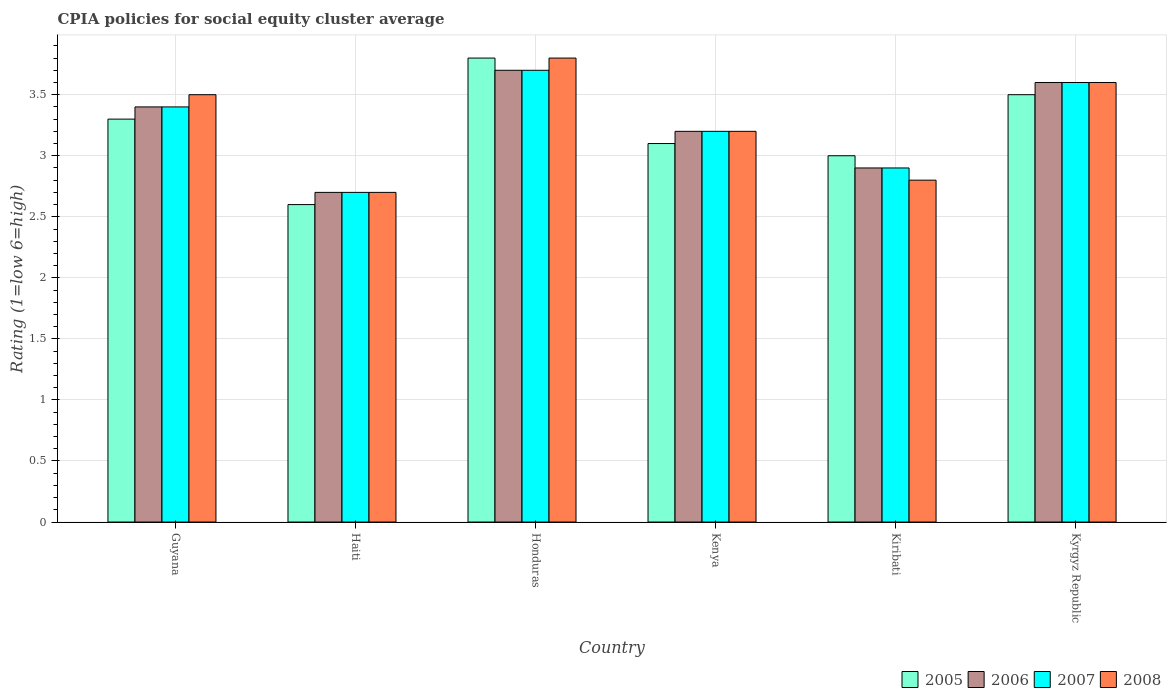Are the number of bars per tick equal to the number of legend labels?
Your response must be concise. Yes. How many bars are there on the 5th tick from the right?
Offer a terse response. 4. What is the label of the 1st group of bars from the left?
Your answer should be compact. Guyana. What is the CPIA rating in 2008 in Kyrgyz Republic?
Provide a short and direct response. 3.6. Across all countries, what is the maximum CPIA rating in 2007?
Provide a short and direct response. 3.7. Across all countries, what is the minimum CPIA rating in 2005?
Make the answer very short. 2.6. In which country was the CPIA rating in 2006 maximum?
Provide a short and direct response. Honduras. In which country was the CPIA rating in 2007 minimum?
Keep it short and to the point. Haiti. What is the total CPIA rating in 2005 in the graph?
Offer a terse response. 19.3. What is the difference between the CPIA rating in 2008 in Honduras and that in Kyrgyz Republic?
Provide a short and direct response. 0.2. What is the average CPIA rating in 2006 per country?
Give a very brief answer. 3.25. What is the difference between the CPIA rating of/in 2005 and CPIA rating of/in 2006 in Honduras?
Make the answer very short. 0.1. What is the ratio of the CPIA rating in 2005 in Kiribati to that in Kyrgyz Republic?
Keep it short and to the point. 0.86. Is the difference between the CPIA rating in 2005 in Haiti and Honduras greater than the difference between the CPIA rating in 2006 in Haiti and Honduras?
Offer a very short reply. No. What is the difference between the highest and the second highest CPIA rating in 2008?
Your answer should be very brief. 0.1. What is the difference between the highest and the lowest CPIA rating in 2006?
Your answer should be very brief. 1. In how many countries, is the CPIA rating in 2005 greater than the average CPIA rating in 2005 taken over all countries?
Provide a short and direct response. 3. Is the sum of the CPIA rating in 2008 in Haiti and Honduras greater than the maximum CPIA rating in 2007 across all countries?
Offer a very short reply. Yes. Is it the case that in every country, the sum of the CPIA rating in 2005 and CPIA rating in 2007 is greater than the sum of CPIA rating in 2006 and CPIA rating in 2008?
Offer a very short reply. No. Is it the case that in every country, the sum of the CPIA rating in 2008 and CPIA rating in 2006 is greater than the CPIA rating in 2005?
Keep it short and to the point. Yes. How many countries are there in the graph?
Make the answer very short. 6. What is the difference between two consecutive major ticks on the Y-axis?
Make the answer very short. 0.5. Does the graph contain grids?
Provide a succinct answer. Yes. Where does the legend appear in the graph?
Provide a short and direct response. Bottom right. How are the legend labels stacked?
Keep it short and to the point. Horizontal. What is the title of the graph?
Offer a terse response. CPIA policies for social equity cluster average. Does "1973" appear as one of the legend labels in the graph?
Offer a terse response. No. What is the label or title of the X-axis?
Your answer should be very brief. Country. What is the Rating (1=low 6=high) in 2007 in Guyana?
Offer a terse response. 3.4. What is the Rating (1=low 6=high) in 2008 in Guyana?
Provide a succinct answer. 3.5. What is the Rating (1=low 6=high) in 2006 in Honduras?
Make the answer very short. 3.7. What is the Rating (1=low 6=high) in 2007 in Honduras?
Your response must be concise. 3.7. What is the Rating (1=low 6=high) in 2006 in Kenya?
Provide a succinct answer. 3.2. What is the Rating (1=low 6=high) in 2008 in Kenya?
Offer a terse response. 3.2. What is the Rating (1=low 6=high) in 2006 in Kiribati?
Your response must be concise. 2.9. What is the Rating (1=low 6=high) in 2008 in Kiribati?
Your response must be concise. 2.8. What is the Rating (1=low 6=high) of 2006 in Kyrgyz Republic?
Your response must be concise. 3.6. Across all countries, what is the maximum Rating (1=low 6=high) of 2005?
Your answer should be very brief. 3.8. Across all countries, what is the maximum Rating (1=low 6=high) in 2007?
Offer a very short reply. 3.7. Across all countries, what is the minimum Rating (1=low 6=high) in 2005?
Your answer should be very brief. 2.6. Across all countries, what is the minimum Rating (1=low 6=high) of 2007?
Provide a succinct answer. 2.7. Across all countries, what is the minimum Rating (1=low 6=high) of 2008?
Give a very brief answer. 2.7. What is the total Rating (1=low 6=high) of 2005 in the graph?
Make the answer very short. 19.3. What is the total Rating (1=low 6=high) in 2006 in the graph?
Ensure brevity in your answer.  19.5. What is the total Rating (1=low 6=high) in 2008 in the graph?
Your response must be concise. 19.6. What is the difference between the Rating (1=low 6=high) of 2005 in Guyana and that in Haiti?
Ensure brevity in your answer.  0.7. What is the difference between the Rating (1=low 6=high) in 2006 in Guyana and that in Haiti?
Make the answer very short. 0.7. What is the difference between the Rating (1=low 6=high) of 2007 in Guyana and that in Haiti?
Ensure brevity in your answer.  0.7. What is the difference between the Rating (1=low 6=high) in 2008 in Guyana and that in Haiti?
Offer a terse response. 0.8. What is the difference between the Rating (1=low 6=high) in 2006 in Guyana and that in Honduras?
Your answer should be very brief. -0.3. What is the difference between the Rating (1=low 6=high) of 2007 in Guyana and that in Honduras?
Your response must be concise. -0.3. What is the difference between the Rating (1=low 6=high) of 2006 in Guyana and that in Kiribati?
Provide a succinct answer. 0.5. What is the difference between the Rating (1=low 6=high) of 2007 in Guyana and that in Kiribati?
Offer a very short reply. 0.5. What is the difference between the Rating (1=low 6=high) in 2006 in Guyana and that in Kyrgyz Republic?
Your answer should be compact. -0.2. What is the difference between the Rating (1=low 6=high) of 2008 in Guyana and that in Kyrgyz Republic?
Your response must be concise. -0.1. What is the difference between the Rating (1=low 6=high) of 2005 in Haiti and that in Honduras?
Make the answer very short. -1.2. What is the difference between the Rating (1=low 6=high) in 2006 in Haiti and that in Honduras?
Offer a terse response. -1. What is the difference between the Rating (1=low 6=high) in 2007 in Haiti and that in Honduras?
Provide a short and direct response. -1. What is the difference between the Rating (1=low 6=high) of 2008 in Haiti and that in Honduras?
Provide a succinct answer. -1.1. What is the difference between the Rating (1=low 6=high) in 2005 in Haiti and that in Kenya?
Provide a succinct answer. -0.5. What is the difference between the Rating (1=low 6=high) of 2006 in Haiti and that in Kenya?
Keep it short and to the point. -0.5. What is the difference between the Rating (1=low 6=high) in 2007 in Haiti and that in Kenya?
Your response must be concise. -0.5. What is the difference between the Rating (1=low 6=high) of 2008 in Haiti and that in Kenya?
Make the answer very short. -0.5. What is the difference between the Rating (1=low 6=high) in 2005 in Haiti and that in Kiribati?
Your answer should be very brief. -0.4. What is the difference between the Rating (1=low 6=high) in 2006 in Haiti and that in Kiribati?
Offer a very short reply. -0.2. What is the difference between the Rating (1=low 6=high) in 2005 in Haiti and that in Kyrgyz Republic?
Offer a very short reply. -0.9. What is the difference between the Rating (1=low 6=high) of 2007 in Haiti and that in Kyrgyz Republic?
Give a very brief answer. -0.9. What is the difference between the Rating (1=low 6=high) in 2008 in Haiti and that in Kyrgyz Republic?
Your answer should be very brief. -0.9. What is the difference between the Rating (1=low 6=high) of 2005 in Honduras and that in Kenya?
Your answer should be very brief. 0.7. What is the difference between the Rating (1=low 6=high) of 2006 in Honduras and that in Kyrgyz Republic?
Keep it short and to the point. 0.1. What is the difference between the Rating (1=low 6=high) in 2008 in Honduras and that in Kyrgyz Republic?
Provide a succinct answer. 0.2. What is the difference between the Rating (1=low 6=high) in 2005 in Kenya and that in Kiribati?
Provide a succinct answer. 0.1. What is the difference between the Rating (1=low 6=high) of 2006 in Kenya and that in Kiribati?
Give a very brief answer. 0.3. What is the difference between the Rating (1=low 6=high) of 2007 in Kenya and that in Kiribati?
Ensure brevity in your answer.  0.3. What is the difference between the Rating (1=low 6=high) of 2008 in Kenya and that in Kiribati?
Your answer should be compact. 0.4. What is the difference between the Rating (1=low 6=high) of 2006 in Kenya and that in Kyrgyz Republic?
Offer a very short reply. -0.4. What is the difference between the Rating (1=low 6=high) of 2007 in Kenya and that in Kyrgyz Republic?
Offer a terse response. -0.4. What is the difference between the Rating (1=low 6=high) of 2005 in Kiribati and that in Kyrgyz Republic?
Offer a terse response. -0.5. What is the difference between the Rating (1=low 6=high) in 2006 in Kiribati and that in Kyrgyz Republic?
Your answer should be very brief. -0.7. What is the difference between the Rating (1=low 6=high) in 2008 in Kiribati and that in Kyrgyz Republic?
Provide a succinct answer. -0.8. What is the difference between the Rating (1=low 6=high) of 2005 in Guyana and the Rating (1=low 6=high) of 2007 in Haiti?
Provide a short and direct response. 0.6. What is the difference between the Rating (1=low 6=high) in 2005 in Guyana and the Rating (1=low 6=high) in 2008 in Haiti?
Ensure brevity in your answer.  0.6. What is the difference between the Rating (1=low 6=high) of 2006 in Guyana and the Rating (1=low 6=high) of 2007 in Haiti?
Provide a short and direct response. 0.7. What is the difference between the Rating (1=low 6=high) of 2006 in Guyana and the Rating (1=low 6=high) of 2008 in Haiti?
Give a very brief answer. 0.7. What is the difference between the Rating (1=low 6=high) of 2007 in Guyana and the Rating (1=low 6=high) of 2008 in Haiti?
Ensure brevity in your answer.  0.7. What is the difference between the Rating (1=low 6=high) of 2005 in Guyana and the Rating (1=low 6=high) of 2006 in Honduras?
Provide a short and direct response. -0.4. What is the difference between the Rating (1=low 6=high) of 2005 in Guyana and the Rating (1=low 6=high) of 2008 in Honduras?
Give a very brief answer. -0.5. What is the difference between the Rating (1=low 6=high) in 2006 in Guyana and the Rating (1=low 6=high) in 2008 in Honduras?
Provide a short and direct response. -0.4. What is the difference between the Rating (1=low 6=high) in 2005 in Guyana and the Rating (1=low 6=high) in 2007 in Kenya?
Give a very brief answer. 0.1. What is the difference between the Rating (1=low 6=high) of 2007 in Guyana and the Rating (1=low 6=high) of 2008 in Kenya?
Ensure brevity in your answer.  0.2. What is the difference between the Rating (1=low 6=high) in 2005 in Guyana and the Rating (1=low 6=high) in 2006 in Kiribati?
Keep it short and to the point. 0.4. What is the difference between the Rating (1=low 6=high) in 2006 in Guyana and the Rating (1=low 6=high) in 2008 in Kiribati?
Your response must be concise. 0.6. What is the difference between the Rating (1=low 6=high) in 2005 in Guyana and the Rating (1=low 6=high) in 2006 in Kyrgyz Republic?
Ensure brevity in your answer.  -0.3. What is the difference between the Rating (1=low 6=high) of 2006 in Guyana and the Rating (1=low 6=high) of 2008 in Kyrgyz Republic?
Ensure brevity in your answer.  -0.2. What is the difference between the Rating (1=low 6=high) in 2005 in Haiti and the Rating (1=low 6=high) in 2006 in Honduras?
Offer a terse response. -1.1. What is the difference between the Rating (1=low 6=high) in 2005 in Haiti and the Rating (1=low 6=high) in 2007 in Honduras?
Keep it short and to the point. -1.1. What is the difference between the Rating (1=low 6=high) of 2006 in Haiti and the Rating (1=low 6=high) of 2007 in Honduras?
Your response must be concise. -1. What is the difference between the Rating (1=low 6=high) of 2006 in Haiti and the Rating (1=low 6=high) of 2008 in Honduras?
Offer a very short reply. -1.1. What is the difference between the Rating (1=low 6=high) in 2007 in Haiti and the Rating (1=low 6=high) in 2008 in Honduras?
Offer a very short reply. -1.1. What is the difference between the Rating (1=low 6=high) in 2005 in Haiti and the Rating (1=low 6=high) in 2007 in Kenya?
Make the answer very short. -0.6. What is the difference between the Rating (1=low 6=high) of 2006 in Haiti and the Rating (1=low 6=high) of 2007 in Kenya?
Make the answer very short. -0.5. What is the difference between the Rating (1=low 6=high) of 2005 in Haiti and the Rating (1=low 6=high) of 2007 in Kiribati?
Offer a very short reply. -0.3. What is the difference between the Rating (1=low 6=high) in 2006 in Haiti and the Rating (1=low 6=high) in 2007 in Kiribati?
Ensure brevity in your answer.  -0.2. What is the difference between the Rating (1=low 6=high) of 2007 in Haiti and the Rating (1=low 6=high) of 2008 in Kiribati?
Offer a very short reply. -0.1. What is the difference between the Rating (1=low 6=high) in 2005 in Haiti and the Rating (1=low 6=high) in 2006 in Kyrgyz Republic?
Offer a terse response. -1. What is the difference between the Rating (1=low 6=high) in 2005 in Haiti and the Rating (1=low 6=high) in 2007 in Kyrgyz Republic?
Keep it short and to the point. -1. What is the difference between the Rating (1=low 6=high) in 2006 in Haiti and the Rating (1=low 6=high) in 2007 in Kyrgyz Republic?
Offer a terse response. -0.9. What is the difference between the Rating (1=low 6=high) in 2006 in Haiti and the Rating (1=low 6=high) in 2008 in Kyrgyz Republic?
Your answer should be very brief. -0.9. What is the difference between the Rating (1=low 6=high) of 2007 in Haiti and the Rating (1=low 6=high) of 2008 in Kyrgyz Republic?
Your response must be concise. -0.9. What is the difference between the Rating (1=low 6=high) in 2005 in Honduras and the Rating (1=low 6=high) in 2008 in Kenya?
Your response must be concise. 0.6. What is the difference between the Rating (1=low 6=high) in 2006 in Honduras and the Rating (1=low 6=high) in 2007 in Kenya?
Your answer should be very brief. 0.5. What is the difference between the Rating (1=low 6=high) of 2005 in Honduras and the Rating (1=low 6=high) of 2006 in Kiribati?
Keep it short and to the point. 0.9. What is the difference between the Rating (1=low 6=high) in 2005 in Honduras and the Rating (1=low 6=high) in 2008 in Kiribati?
Keep it short and to the point. 1. What is the difference between the Rating (1=low 6=high) of 2006 in Honduras and the Rating (1=low 6=high) of 2007 in Kiribati?
Your answer should be very brief. 0.8. What is the difference between the Rating (1=low 6=high) of 2007 in Honduras and the Rating (1=low 6=high) of 2008 in Kiribati?
Your response must be concise. 0.9. What is the difference between the Rating (1=low 6=high) in 2005 in Honduras and the Rating (1=low 6=high) in 2007 in Kyrgyz Republic?
Your answer should be very brief. 0.2. What is the difference between the Rating (1=low 6=high) in 2006 in Honduras and the Rating (1=low 6=high) in 2007 in Kyrgyz Republic?
Provide a succinct answer. 0.1. What is the difference between the Rating (1=low 6=high) of 2007 in Honduras and the Rating (1=low 6=high) of 2008 in Kyrgyz Republic?
Ensure brevity in your answer.  0.1. What is the difference between the Rating (1=low 6=high) of 2005 in Kenya and the Rating (1=low 6=high) of 2006 in Kiribati?
Ensure brevity in your answer.  0.2. What is the difference between the Rating (1=low 6=high) of 2006 in Kenya and the Rating (1=low 6=high) of 2007 in Kiribati?
Ensure brevity in your answer.  0.3. What is the difference between the Rating (1=low 6=high) of 2006 in Kenya and the Rating (1=low 6=high) of 2008 in Kiribati?
Give a very brief answer. 0.4. What is the difference between the Rating (1=low 6=high) of 2007 in Kenya and the Rating (1=low 6=high) of 2008 in Kiribati?
Offer a very short reply. 0.4. What is the difference between the Rating (1=low 6=high) in 2005 in Kenya and the Rating (1=low 6=high) in 2006 in Kyrgyz Republic?
Your response must be concise. -0.5. What is the difference between the Rating (1=low 6=high) of 2006 in Kenya and the Rating (1=low 6=high) of 2007 in Kyrgyz Republic?
Provide a succinct answer. -0.4. What is the difference between the Rating (1=low 6=high) of 2006 in Kenya and the Rating (1=low 6=high) of 2008 in Kyrgyz Republic?
Give a very brief answer. -0.4. What is the difference between the Rating (1=low 6=high) in 2007 in Kenya and the Rating (1=low 6=high) in 2008 in Kyrgyz Republic?
Provide a succinct answer. -0.4. What is the difference between the Rating (1=low 6=high) of 2005 in Kiribati and the Rating (1=low 6=high) of 2006 in Kyrgyz Republic?
Keep it short and to the point. -0.6. What is the difference between the Rating (1=low 6=high) in 2005 in Kiribati and the Rating (1=low 6=high) in 2007 in Kyrgyz Republic?
Offer a very short reply. -0.6. What is the difference between the Rating (1=low 6=high) in 2005 in Kiribati and the Rating (1=low 6=high) in 2008 in Kyrgyz Republic?
Ensure brevity in your answer.  -0.6. What is the average Rating (1=low 6=high) in 2005 per country?
Keep it short and to the point. 3.22. What is the average Rating (1=low 6=high) in 2006 per country?
Give a very brief answer. 3.25. What is the average Rating (1=low 6=high) of 2007 per country?
Give a very brief answer. 3.25. What is the average Rating (1=low 6=high) of 2008 per country?
Make the answer very short. 3.27. What is the difference between the Rating (1=low 6=high) in 2005 and Rating (1=low 6=high) in 2007 in Guyana?
Your answer should be compact. -0.1. What is the difference between the Rating (1=low 6=high) of 2007 and Rating (1=low 6=high) of 2008 in Guyana?
Give a very brief answer. -0.1. What is the difference between the Rating (1=low 6=high) of 2005 and Rating (1=low 6=high) of 2006 in Haiti?
Offer a very short reply. -0.1. What is the difference between the Rating (1=low 6=high) in 2006 and Rating (1=low 6=high) in 2007 in Haiti?
Your response must be concise. 0. What is the difference between the Rating (1=low 6=high) in 2006 and Rating (1=low 6=high) in 2008 in Haiti?
Provide a succinct answer. 0. What is the difference between the Rating (1=low 6=high) in 2005 and Rating (1=low 6=high) in 2007 in Honduras?
Offer a terse response. 0.1. What is the difference between the Rating (1=low 6=high) of 2005 and Rating (1=low 6=high) of 2008 in Honduras?
Provide a succinct answer. 0. What is the difference between the Rating (1=low 6=high) in 2005 and Rating (1=low 6=high) in 2008 in Kenya?
Offer a very short reply. -0.1. What is the difference between the Rating (1=low 6=high) in 2006 and Rating (1=low 6=high) in 2007 in Kenya?
Provide a succinct answer. 0. What is the difference between the Rating (1=low 6=high) in 2006 and Rating (1=low 6=high) in 2008 in Kenya?
Your response must be concise. 0. What is the difference between the Rating (1=low 6=high) in 2006 and Rating (1=low 6=high) in 2007 in Kiribati?
Offer a terse response. 0. What is the difference between the Rating (1=low 6=high) in 2006 and Rating (1=low 6=high) in 2008 in Kiribati?
Your answer should be very brief. 0.1. What is the difference between the Rating (1=low 6=high) of 2007 and Rating (1=low 6=high) of 2008 in Kiribati?
Your response must be concise. 0.1. What is the difference between the Rating (1=low 6=high) of 2006 and Rating (1=low 6=high) of 2007 in Kyrgyz Republic?
Your response must be concise. 0. What is the difference between the Rating (1=low 6=high) in 2006 and Rating (1=low 6=high) in 2008 in Kyrgyz Republic?
Give a very brief answer. 0. What is the difference between the Rating (1=low 6=high) in 2007 and Rating (1=low 6=high) in 2008 in Kyrgyz Republic?
Your answer should be very brief. 0. What is the ratio of the Rating (1=low 6=high) in 2005 in Guyana to that in Haiti?
Provide a succinct answer. 1.27. What is the ratio of the Rating (1=low 6=high) in 2006 in Guyana to that in Haiti?
Provide a short and direct response. 1.26. What is the ratio of the Rating (1=low 6=high) of 2007 in Guyana to that in Haiti?
Offer a very short reply. 1.26. What is the ratio of the Rating (1=low 6=high) in 2008 in Guyana to that in Haiti?
Your answer should be compact. 1.3. What is the ratio of the Rating (1=low 6=high) of 2005 in Guyana to that in Honduras?
Your response must be concise. 0.87. What is the ratio of the Rating (1=low 6=high) of 2006 in Guyana to that in Honduras?
Make the answer very short. 0.92. What is the ratio of the Rating (1=low 6=high) in 2007 in Guyana to that in Honduras?
Offer a terse response. 0.92. What is the ratio of the Rating (1=low 6=high) in 2008 in Guyana to that in Honduras?
Offer a terse response. 0.92. What is the ratio of the Rating (1=low 6=high) in 2005 in Guyana to that in Kenya?
Give a very brief answer. 1.06. What is the ratio of the Rating (1=low 6=high) of 2006 in Guyana to that in Kenya?
Make the answer very short. 1.06. What is the ratio of the Rating (1=low 6=high) of 2008 in Guyana to that in Kenya?
Provide a succinct answer. 1.09. What is the ratio of the Rating (1=low 6=high) in 2005 in Guyana to that in Kiribati?
Give a very brief answer. 1.1. What is the ratio of the Rating (1=low 6=high) of 2006 in Guyana to that in Kiribati?
Keep it short and to the point. 1.17. What is the ratio of the Rating (1=low 6=high) of 2007 in Guyana to that in Kiribati?
Offer a very short reply. 1.17. What is the ratio of the Rating (1=low 6=high) in 2005 in Guyana to that in Kyrgyz Republic?
Your response must be concise. 0.94. What is the ratio of the Rating (1=low 6=high) in 2008 in Guyana to that in Kyrgyz Republic?
Keep it short and to the point. 0.97. What is the ratio of the Rating (1=low 6=high) of 2005 in Haiti to that in Honduras?
Make the answer very short. 0.68. What is the ratio of the Rating (1=low 6=high) in 2006 in Haiti to that in Honduras?
Your answer should be compact. 0.73. What is the ratio of the Rating (1=low 6=high) in 2007 in Haiti to that in Honduras?
Your answer should be compact. 0.73. What is the ratio of the Rating (1=low 6=high) of 2008 in Haiti to that in Honduras?
Give a very brief answer. 0.71. What is the ratio of the Rating (1=low 6=high) in 2005 in Haiti to that in Kenya?
Provide a short and direct response. 0.84. What is the ratio of the Rating (1=low 6=high) of 2006 in Haiti to that in Kenya?
Your answer should be very brief. 0.84. What is the ratio of the Rating (1=low 6=high) in 2007 in Haiti to that in Kenya?
Your answer should be very brief. 0.84. What is the ratio of the Rating (1=low 6=high) in 2008 in Haiti to that in Kenya?
Provide a succinct answer. 0.84. What is the ratio of the Rating (1=low 6=high) in 2005 in Haiti to that in Kiribati?
Provide a short and direct response. 0.87. What is the ratio of the Rating (1=low 6=high) in 2006 in Haiti to that in Kiribati?
Offer a very short reply. 0.93. What is the ratio of the Rating (1=low 6=high) of 2005 in Haiti to that in Kyrgyz Republic?
Give a very brief answer. 0.74. What is the ratio of the Rating (1=low 6=high) in 2007 in Haiti to that in Kyrgyz Republic?
Your answer should be very brief. 0.75. What is the ratio of the Rating (1=low 6=high) of 2008 in Haiti to that in Kyrgyz Republic?
Ensure brevity in your answer.  0.75. What is the ratio of the Rating (1=low 6=high) in 2005 in Honduras to that in Kenya?
Make the answer very short. 1.23. What is the ratio of the Rating (1=low 6=high) of 2006 in Honduras to that in Kenya?
Give a very brief answer. 1.16. What is the ratio of the Rating (1=low 6=high) of 2007 in Honduras to that in Kenya?
Give a very brief answer. 1.16. What is the ratio of the Rating (1=low 6=high) of 2008 in Honduras to that in Kenya?
Offer a terse response. 1.19. What is the ratio of the Rating (1=low 6=high) in 2005 in Honduras to that in Kiribati?
Make the answer very short. 1.27. What is the ratio of the Rating (1=low 6=high) of 2006 in Honduras to that in Kiribati?
Provide a succinct answer. 1.28. What is the ratio of the Rating (1=low 6=high) in 2007 in Honduras to that in Kiribati?
Keep it short and to the point. 1.28. What is the ratio of the Rating (1=low 6=high) in 2008 in Honduras to that in Kiribati?
Ensure brevity in your answer.  1.36. What is the ratio of the Rating (1=low 6=high) of 2005 in Honduras to that in Kyrgyz Republic?
Offer a terse response. 1.09. What is the ratio of the Rating (1=low 6=high) of 2006 in Honduras to that in Kyrgyz Republic?
Your answer should be very brief. 1.03. What is the ratio of the Rating (1=low 6=high) of 2007 in Honduras to that in Kyrgyz Republic?
Keep it short and to the point. 1.03. What is the ratio of the Rating (1=low 6=high) in 2008 in Honduras to that in Kyrgyz Republic?
Ensure brevity in your answer.  1.06. What is the ratio of the Rating (1=low 6=high) in 2005 in Kenya to that in Kiribati?
Your answer should be compact. 1.03. What is the ratio of the Rating (1=low 6=high) of 2006 in Kenya to that in Kiribati?
Your response must be concise. 1.1. What is the ratio of the Rating (1=low 6=high) in 2007 in Kenya to that in Kiribati?
Provide a succinct answer. 1.1. What is the ratio of the Rating (1=low 6=high) of 2008 in Kenya to that in Kiribati?
Provide a succinct answer. 1.14. What is the ratio of the Rating (1=low 6=high) of 2005 in Kenya to that in Kyrgyz Republic?
Your answer should be compact. 0.89. What is the ratio of the Rating (1=low 6=high) of 2006 in Kenya to that in Kyrgyz Republic?
Give a very brief answer. 0.89. What is the ratio of the Rating (1=low 6=high) in 2007 in Kenya to that in Kyrgyz Republic?
Your response must be concise. 0.89. What is the ratio of the Rating (1=low 6=high) in 2008 in Kenya to that in Kyrgyz Republic?
Your answer should be compact. 0.89. What is the ratio of the Rating (1=low 6=high) of 2006 in Kiribati to that in Kyrgyz Republic?
Your answer should be very brief. 0.81. What is the ratio of the Rating (1=low 6=high) of 2007 in Kiribati to that in Kyrgyz Republic?
Make the answer very short. 0.81. What is the ratio of the Rating (1=low 6=high) in 2008 in Kiribati to that in Kyrgyz Republic?
Your response must be concise. 0.78. What is the difference between the highest and the second highest Rating (1=low 6=high) of 2005?
Offer a terse response. 0.3. What is the difference between the highest and the second highest Rating (1=low 6=high) in 2007?
Provide a short and direct response. 0.1. What is the difference between the highest and the lowest Rating (1=low 6=high) of 2006?
Provide a short and direct response. 1. What is the difference between the highest and the lowest Rating (1=low 6=high) of 2007?
Give a very brief answer. 1. What is the difference between the highest and the lowest Rating (1=low 6=high) in 2008?
Offer a very short reply. 1.1. 